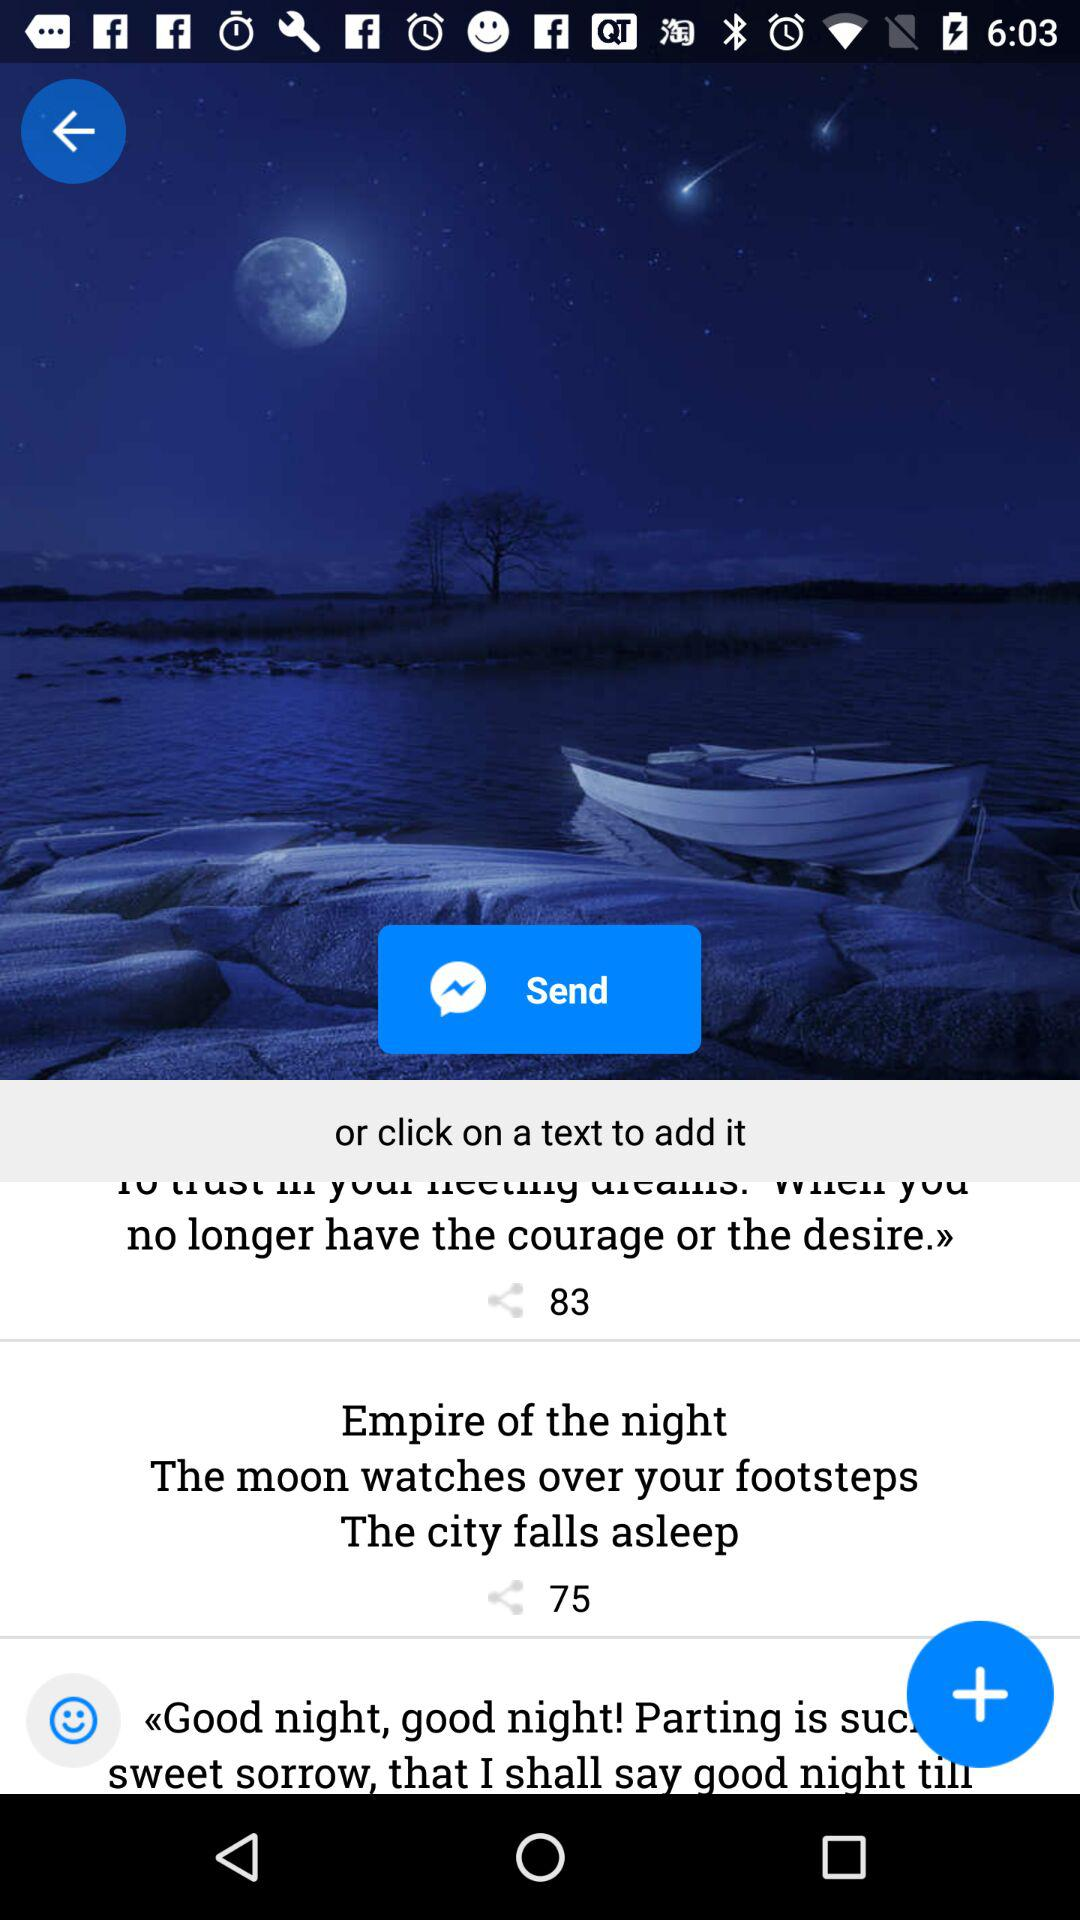Which applications are available for sharing the post?
When the provided information is insufficient, respond with <no answer>. <no answer> 